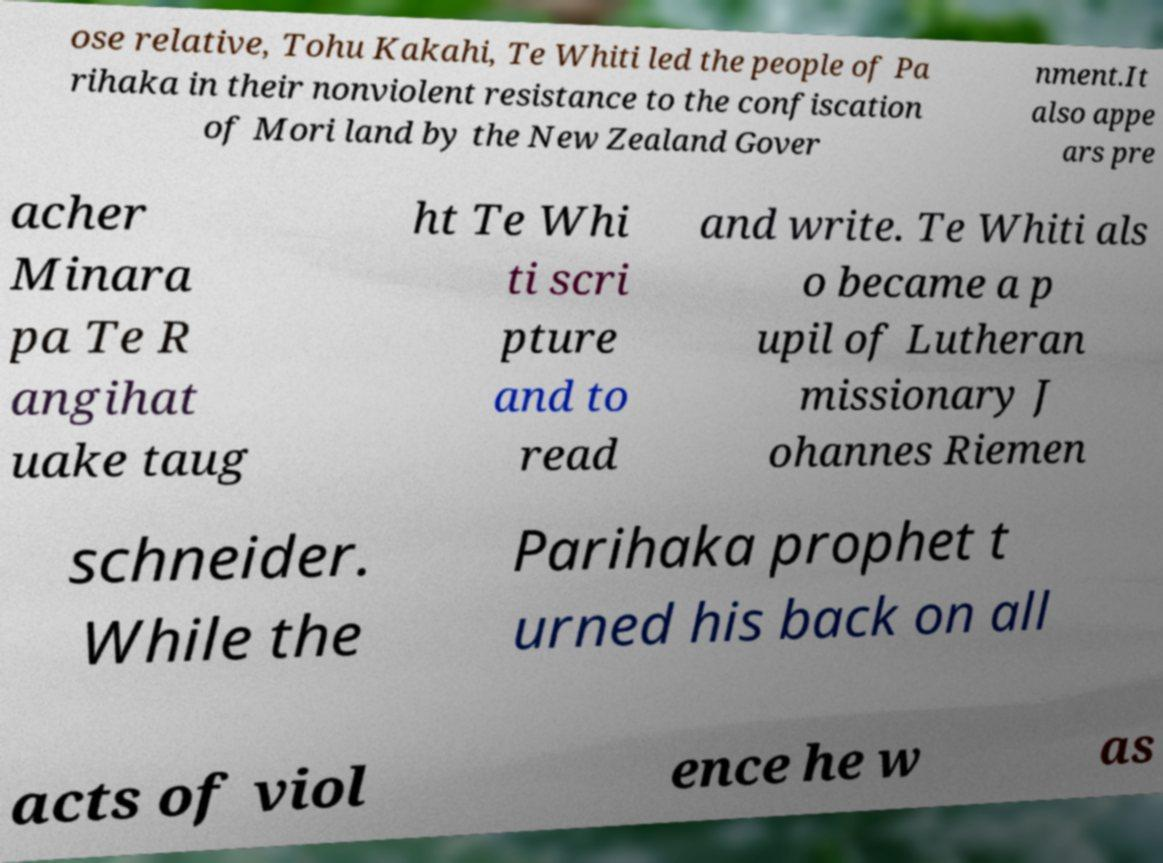Could you assist in decoding the text presented in this image and type it out clearly? ose relative, Tohu Kakahi, Te Whiti led the people of Pa rihaka in their nonviolent resistance to the confiscation of Mori land by the New Zealand Gover nment.It also appe ars pre acher Minara pa Te R angihat uake taug ht Te Whi ti scri pture and to read and write. Te Whiti als o became a p upil of Lutheran missionary J ohannes Riemen schneider. While the Parihaka prophet t urned his back on all acts of viol ence he w as 